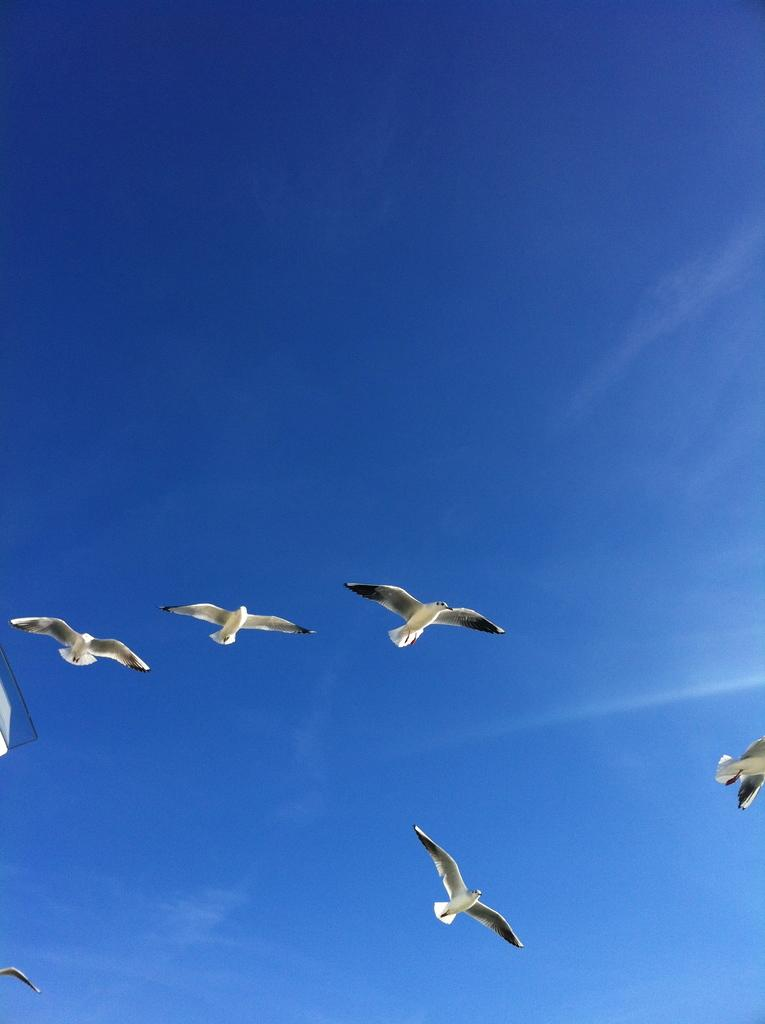What is happening in the sky in the image? There are birds flying in the sky in the image. What can be seen on the left side of the image? There is an object on the left side of the image. What color is the sky in the background of the image? The sky is blue in the background of the image. What type of grain is being harvested in the downtown area in the image? There is no grain or downtown area present in the image; it features birds flying in the sky and an object on the left side. 